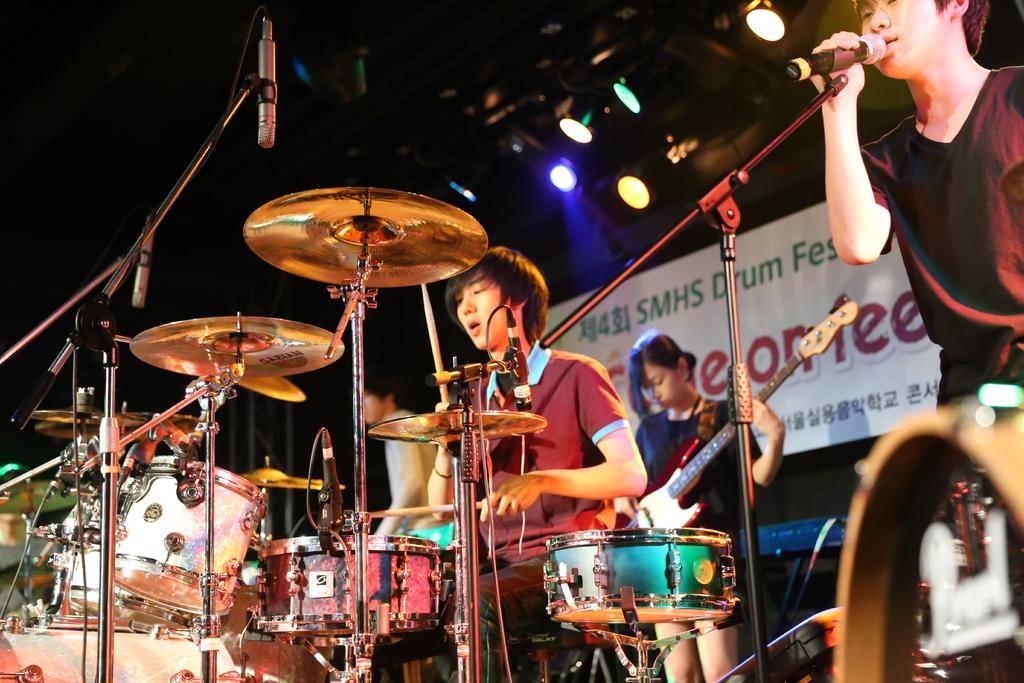What are the people in the image doing? The people in the image are playing musical instruments. What else can be seen in the image besides the people playing instruments? There is a poster visible in the image, as well as lights. What type of flower is being advertised on the poster in the image? There is no flower being advertised on the poster in the image; the poster is not related to any advertisement. 